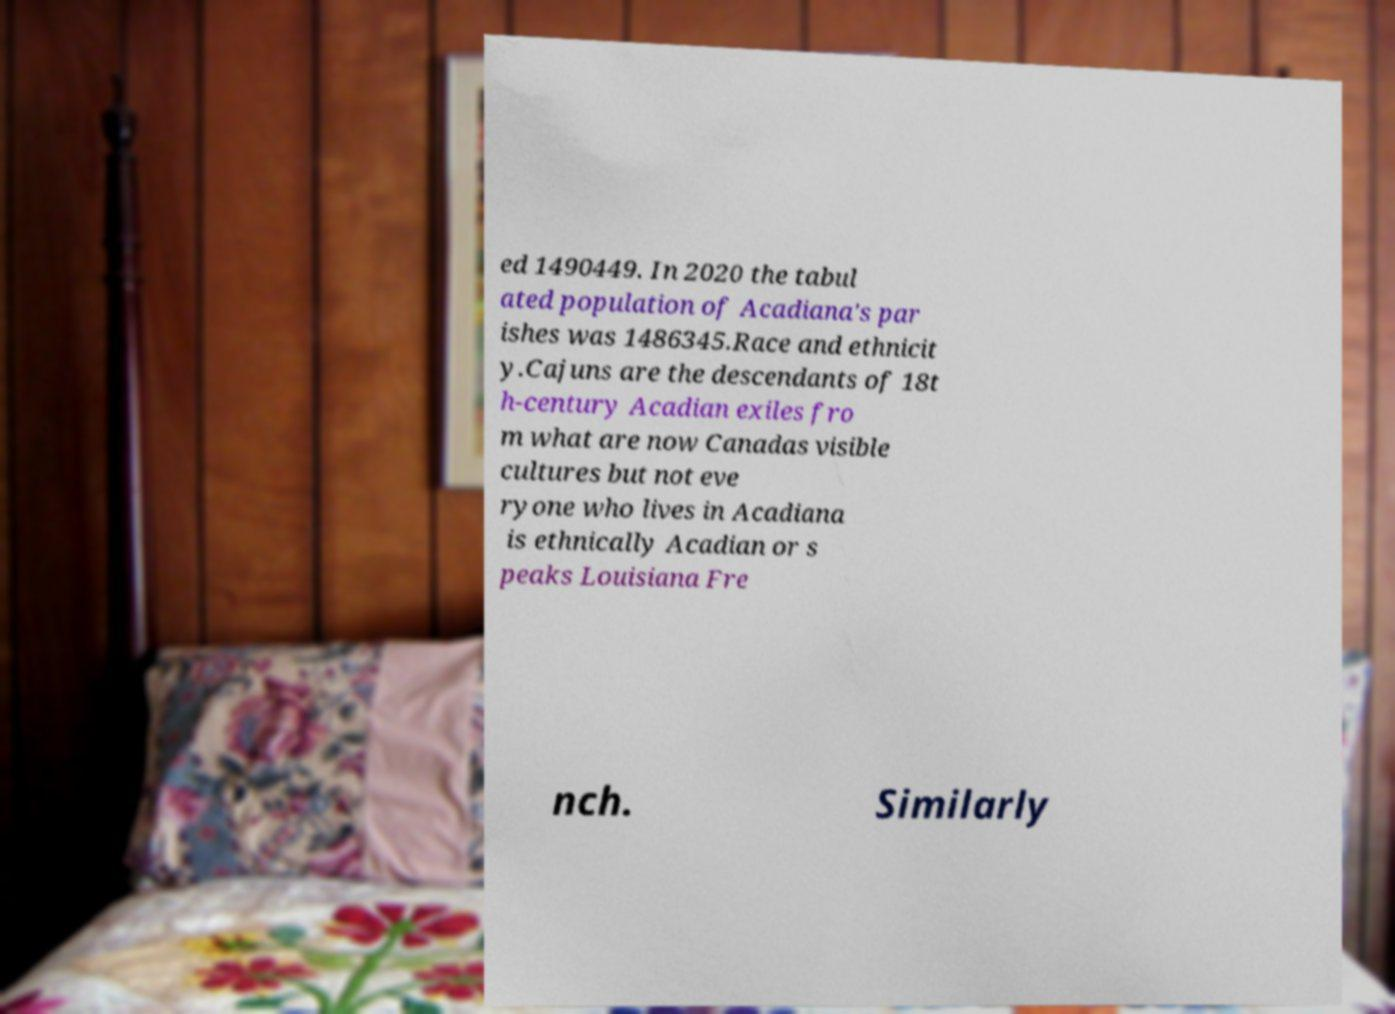Please read and relay the text visible in this image. What does it say? ed 1490449. In 2020 the tabul ated population of Acadiana's par ishes was 1486345.Race and ethnicit y.Cajuns are the descendants of 18t h-century Acadian exiles fro m what are now Canadas visible cultures but not eve ryone who lives in Acadiana is ethnically Acadian or s peaks Louisiana Fre nch. Similarly 